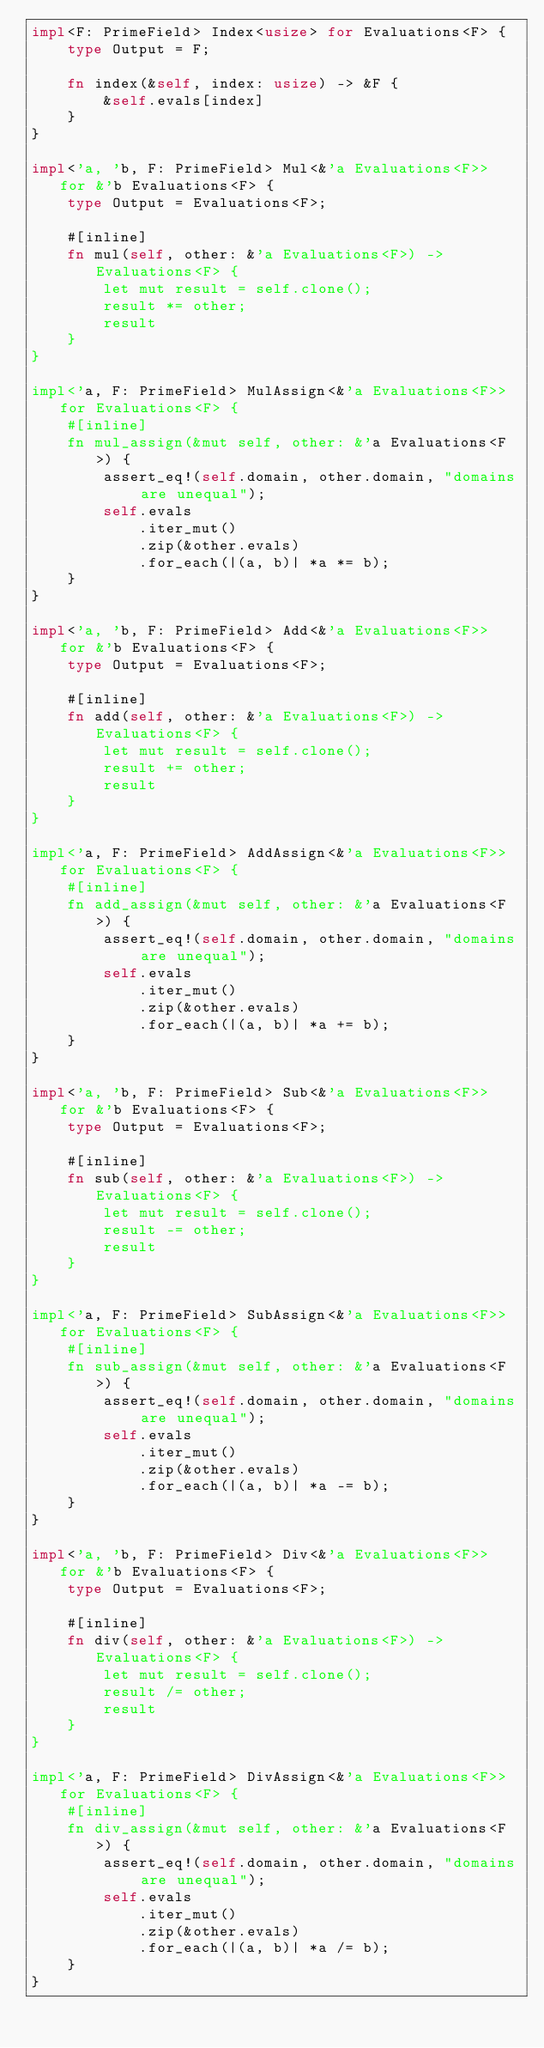<code> <loc_0><loc_0><loc_500><loc_500><_Rust_>impl<F: PrimeField> Index<usize> for Evaluations<F> {
    type Output = F;

    fn index(&self, index: usize) -> &F {
        &self.evals[index]
    }
}

impl<'a, 'b, F: PrimeField> Mul<&'a Evaluations<F>> for &'b Evaluations<F> {
    type Output = Evaluations<F>;

    #[inline]
    fn mul(self, other: &'a Evaluations<F>) -> Evaluations<F> {
        let mut result = self.clone();
        result *= other;
        result
    }
}

impl<'a, F: PrimeField> MulAssign<&'a Evaluations<F>> for Evaluations<F> {
    #[inline]
    fn mul_assign(&mut self, other: &'a Evaluations<F>) {
        assert_eq!(self.domain, other.domain, "domains are unequal");
        self.evals
            .iter_mut()
            .zip(&other.evals)
            .for_each(|(a, b)| *a *= b);
    }
}

impl<'a, 'b, F: PrimeField> Add<&'a Evaluations<F>> for &'b Evaluations<F> {
    type Output = Evaluations<F>;

    #[inline]
    fn add(self, other: &'a Evaluations<F>) -> Evaluations<F> {
        let mut result = self.clone();
        result += other;
        result
    }
}

impl<'a, F: PrimeField> AddAssign<&'a Evaluations<F>> for Evaluations<F> {
    #[inline]
    fn add_assign(&mut self, other: &'a Evaluations<F>) {
        assert_eq!(self.domain, other.domain, "domains are unequal");
        self.evals
            .iter_mut()
            .zip(&other.evals)
            .for_each(|(a, b)| *a += b);
    }
}

impl<'a, 'b, F: PrimeField> Sub<&'a Evaluations<F>> for &'b Evaluations<F> {
    type Output = Evaluations<F>;

    #[inline]
    fn sub(self, other: &'a Evaluations<F>) -> Evaluations<F> {
        let mut result = self.clone();
        result -= other;
        result
    }
}

impl<'a, F: PrimeField> SubAssign<&'a Evaluations<F>> for Evaluations<F> {
    #[inline]
    fn sub_assign(&mut self, other: &'a Evaluations<F>) {
        assert_eq!(self.domain, other.domain, "domains are unequal");
        self.evals
            .iter_mut()
            .zip(&other.evals)
            .for_each(|(a, b)| *a -= b);
    }
}

impl<'a, 'b, F: PrimeField> Div<&'a Evaluations<F>> for &'b Evaluations<F> {
    type Output = Evaluations<F>;

    #[inline]
    fn div(self, other: &'a Evaluations<F>) -> Evaluations<F> {
        let mut result = self.clone();
        result /= other;
        result
    }
}

impl<'a, F: PrimeField> DivAssign<&'a Evaluations<F>> for Evaluations<F> {
    #[inline]
    fn div_assign(&mut self, other: &'a Evaluations<F>) {
        assert_eq!(self.domain, other.domain, "domains are unequal");
        self.evals
            .iter_mut()
            .zip(&other.evals)
            .for_each(|(a, b)| *a /= b);
    }
}
</code> 